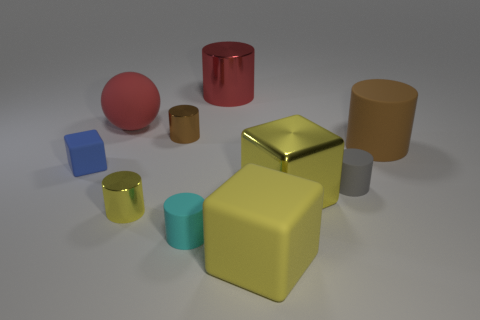Subtract all yellow cubes. How many were subtracted if there are1yellow cubes left? 1 Subtract all big red metal cylinders. How many cylinders are left? 5 Subtract all blue balls. How many yellow cubes are left? 2 Subtract 4 cylinders. How many cylinders are left? 2 Subtract all red cylinders. How many cylinders are left? 5 Subtract all cyan cubes. Subtract all purple cylinders. How many cubes are left? 3 Subtract all balls. How many objects are left? 9 Subtract all blue cubes. Subtract all tiny cyan things. How many objects are left? 8 Add 8 large metal things. How many large metal things are left? 10 Add 6 tiny metallic things. How many tiny metallic things exist? 8 